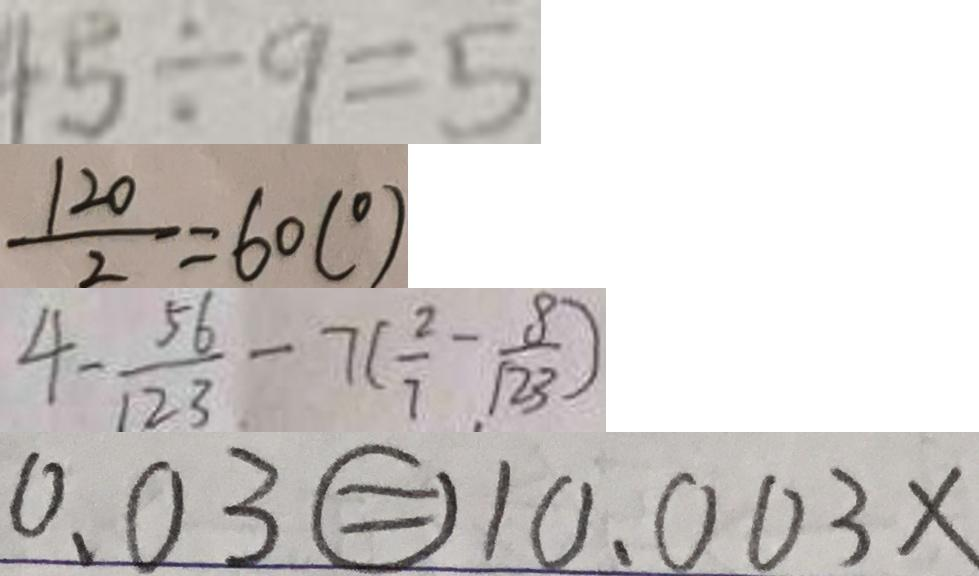<formula> <loc_0><loc_0><loc_500><loc_500>4 5 \div 9 = 5 
 \frac { 1 2 0 } { 2 } = 6 0 ( ^ { \circ } ) 
 4 - \frac { 5 6 } { 1 2 3 } - 7 ( \frac { 2 } { 7 } - \frac { 8 } { 1 2 3 } ) 
 0 . 0 3 \textcircled { = } 1 0 . 0 0 3 x</formula> 